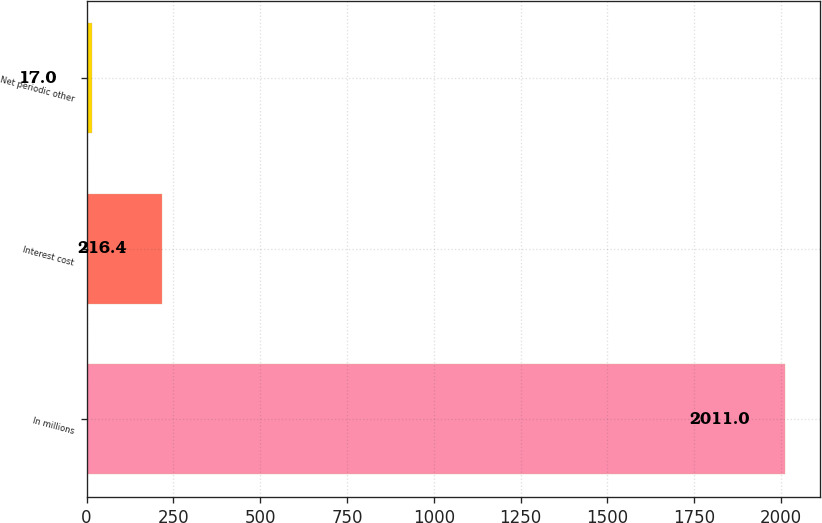Convert chart to OTSL. <chart><loc_0><loc_0><loc_500><loc_500><bar_chart><fcel>In millions<fcel>Interest cost<fcel>Net periodic other<nl><fcel>2011<fcel>216.4<fcel>17<nl></chart> 